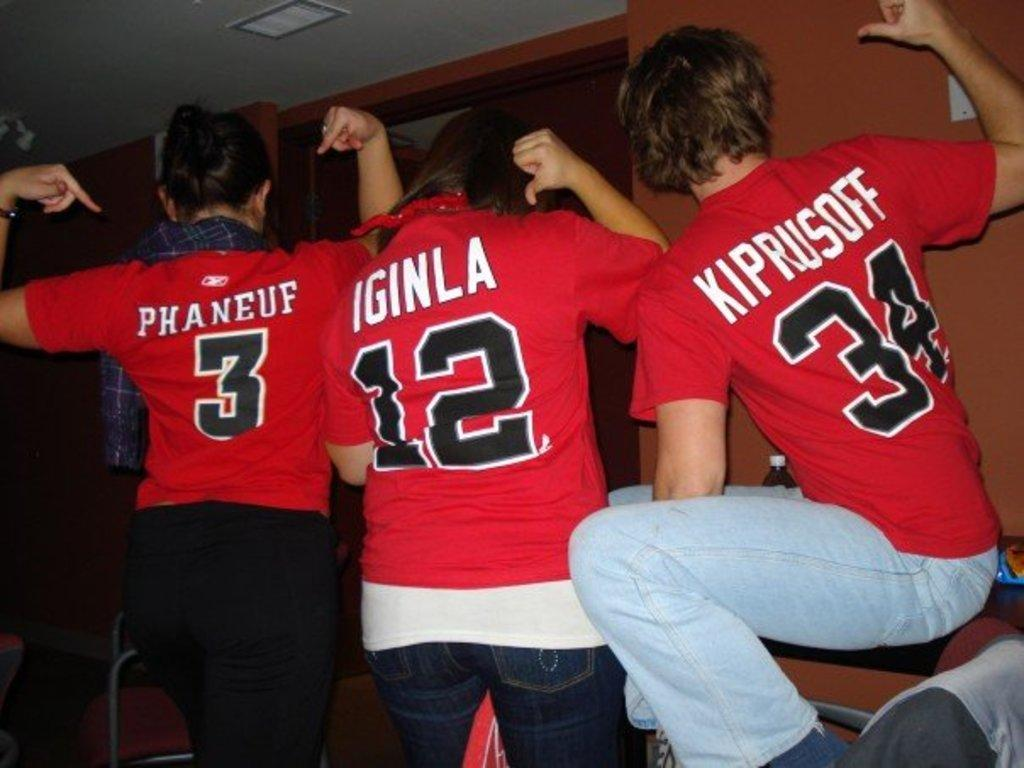<image>
Summarize the visual content of the image. Fans wear jerseys with numbers 3, 12, and 34 written on them 